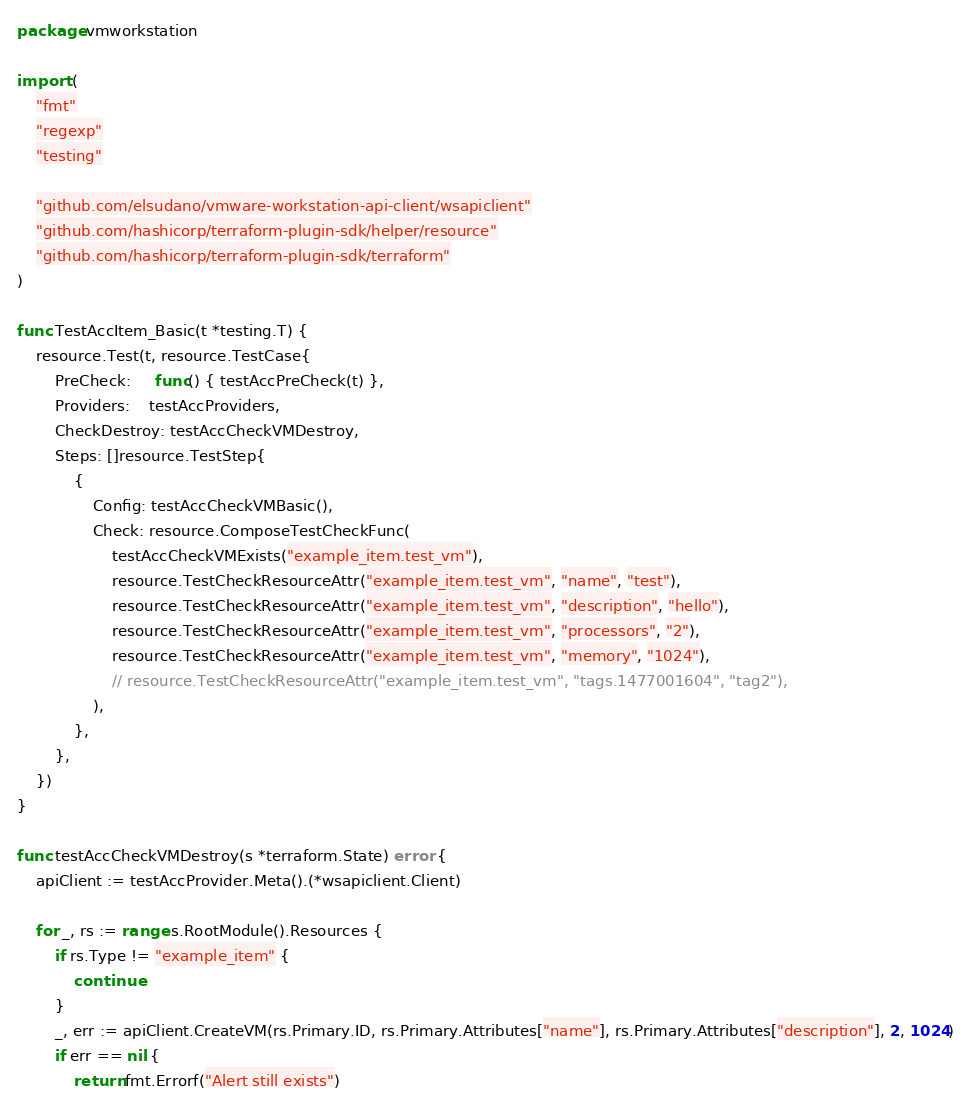Convert code to text. <code><loc_0><loc_0><loc_500><loc_500><_Go_>package vmworkstation

import (
	"fmt"
	"regexp"
	"testing"

	"github.com/elsudano/vmware-workstation-api-client/wsapiclient"
	"github.com/hashicorp/terraform-plugin-sdk/helper/resource"
	"github.com/hashicorp/terraform-plugin-sdk/terraform"
)

func TestAccItem_Basic(t *testing.T) {
	resource.Test(t, resource.TestCase{
		PreCheck:     func() { testAccPreCheck(t) },
		Providers:    testAccProviders,
		CheckDestroy: testAccCheckVMDestroy,
		Steps: []resource.TestStep{
			{
				Config: testAccCheckVMBasic(),
				Check: resource.ComposeTestCheckFunc(
					testAccCheckVMExists("example_item.test_vm"),
					resource.TestCheckResourceAttr("example_item.test_vm", "name", "test"),
					resource.TestCheckResourceAttr("example_item.test_vm", "description", "hello"),
					resource.TestCheckResourceAttr("example_item.test_vm", "processors", "2"),
					resource.TestCheckResourceAttr("example_item.test_vm", "memory", "1024"),
					// resource.TestCheckResourceAttr("example_item.test_vm", "tags.1477001604", "tag2"),
				),
			},
		},
	})
}

func testAccCheckVMDestroy(s *terraform.State) error {
	apiClient := testAccProvider.Meta().(*wsapiclient.Client)

	for _, rs := range s.RootModule().Resources {
		if rs.Type != "example_item" {
			continue
		}
		_, err := apiClient.CreateVM(rs.Primary.ID, rs.Primary.Attributes["name"], rs.Primary.Attributes["description"], 2, 1024)
		if err == nil {
			return fmt.Errorf("Alert still exists")</code> 